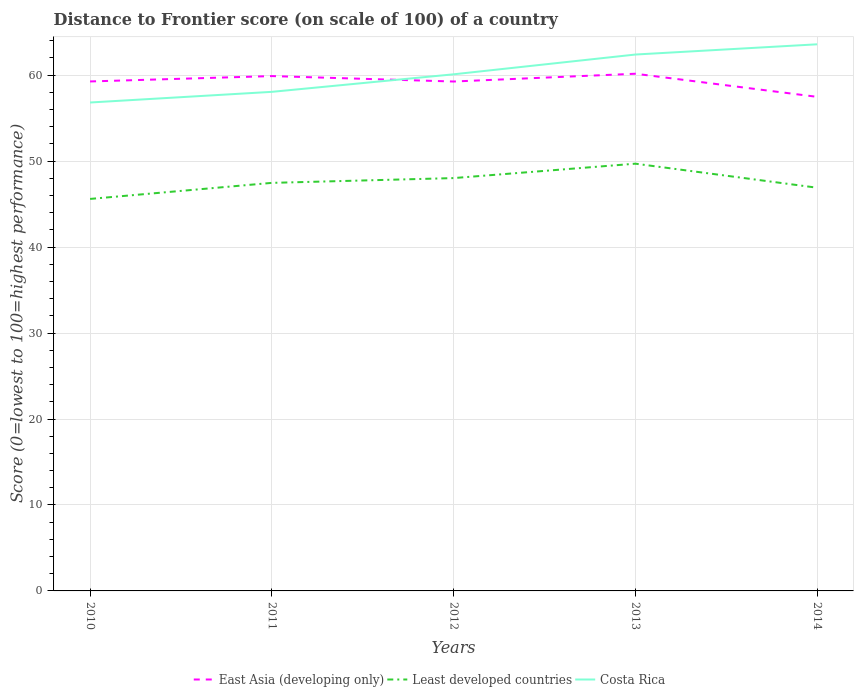Does the line corresponding to East Asia (developing only) intersect with the line corresponding to Least developed countries?
Keep it short and to the point. No. Across all years, what is the maximum distance to frontier score of in Least developed countries?
Provide a short and direct response. 45.6. What is the total distance to frontier score of in East Asia (developing only) in the graph?
Ensure brevity in your answer.  2.69. What is the difference between the highest and the second highest distance to frontier score of in Costa Rica?
Your answer should be compact. 6.77. Is the distance to frontier score of in Least developed countries strictly greater than the distance to frontier score of in East Asia (developing only) over the years?
Offer a terse response. Yes. How many lines are there?
Provide a succinct answer. 3. How many years are there in the graph?
Give a very brief answer. 5. What is the difference between two consecutive major ticks on the Y-axis?
Offer a terse response. 10. Does the graph contain any zero values?
Ensure brevity in your answer.  No. Does the graph contain grids?
Keep it short and to the point. Yes. How many legend labels are there?
Give a very brief answer. 3. How are the legend labels stacked?
Your response must be concise. Horizontal. What is the title of the graph?
Keep it short and to the point. Distance to Frontier score (on scale of 100) of a country. Does "Tuvalu" appear as one of the legend labels in the graph?
Your answer should be compact. No. What is the label or title of the Y-axis?
Give a very brief answer. Score (0=lowest to 100=highest performance). What is the Score (0=lowest to 100=highest performance) in East Asia (developing only) in 2010?
Provide a short and direct response. 59.27. What is the Score (0=lowest to 100=highest performance) of Least developed countries in 2010?
Make the answer very short. 45.6. What is the Score (0=lowest to 100=highest performance) of Costa Rica in 2010?
Offer a very short reply. 56.82. What is the Score (0=lowest to 100=highest performance) in East Asia (developing only) in 2011?
Make the answer very short. 59.89. What is the Score (0=lowest to 100=highest performance) of Least developed countries in 2011?
Offer a very short reply. 47.47. What is the Score (0=lowest to 100=highest performance) of Costa Rica in 2011?
Your answer should be very brief. 58.06. What is the Score (0=lowest to 100=highest performance) in East Asia (developing only) in 2012?
Your answer should be very brief. 59.26. What is the Score (0=lowest to 100=highest performance) in Least developed countries in 2012?
Give a very brief answer. 48.03. What is the Score (0=lowest to 100=highest performance) in Costa Rica in 2012?
Provide a short and direct response. 60.1. What is the Score (0=lowest to 100=highest performance) in East Asia (developing only) in 2013?
Your answer should be very brief. 60.17. What is the Score (0=lowest to 100=highest performance) of Least developed countries in 2013?
Offer a terse response. 49.7. What is the Score (0=lowest to 100=highest performance) of Costa Rica in 2013?
Provide a short and direct response. 62.4. What is the Score (0=lowest to 100=highest performance) in East Asia (developing only) in 2014?
Keep it short and to the point. 57.48. What is the Score (0=lowest to 100=highest performance) in Least developed countries in 2014?
Keep it short and to the point. 46.91. What is the Score (0=lowest to 100=highest performance) of Costa Rica in 2014?
Offer a terse response. 63.59. Across all years, what is the maximum Score (0=lowest to 100=highest performance) of East Asia (developing only)?
Your answer should be compact. 60.17. Across all years, what is the maximum Score (0=lowest to 100=highest performance) of Least developed countries?
Provide a succinct answer. 49.7. Across all years, what is the maximum Score (0=lowest to 100=highest performance) of Costa Rica?
Your response must be concise. 63.59. Across all years, what is the minimum Score (0=lowest to 100=highest performance) in East Asia (developing only)?
Offer a very short reply. 57.48. Across all years, what is the minimum Score (0=lowest to 100=highest performance) in Least developed countries?
Keep it short and to the point. 45.6. Across all years, what is the minimum Score (0=lowest to 100=highest performance) of Costa Rica?
Your answer should be very brief. 56.82. What is the total Score (0=lowest to 100=highest performance) in East Asia (developing only) in the graph?
Provide a succinct answer. 296.07. What is the total Score (0=lowest to 100=highest performance) in Least developed countries in the graph?
Make the answer very short. 237.71. What is the total Score (0=lowest to 100=highest performance) of Costa Rica in the graph?
Offer a very short reply. 300.97. What is the difference between the Score (0=lowest to 100=highest performance) of East Asia (developing only) in 2010 and that in 2011?
Make the answer very short. -0.63. What is the difference between the Score (0=lowest to 100=highest performance) in Least developed countries in 2010 and that in 2011?
Make the answer very short. -1.87. What is the difference between the Score (0=lowest to 100=highest performance) of Costa Rica in 2010 and that in 2011?
Provide a short and direct response. -1.24. What is the difference between the Score (0=lowest to 100=highest performance) of East Asia (developing only) in 2010 and that in 2012?
Offer a terse response. 0.01. What is the difference between the Score (0=lowest to 100=highest performance) of Least developed countries in 2010 and that in 2012?
Provide a short and direct response. -2.43. What is the difference between the Score (0=lowest to 100=highest performance) in Costa Rica in 2010 and that in 2012?
Give a very brief answer. -3.28. What is the difference between the Score (0=lowest to 100=highest performance) in East Asia (developing only) in 2010 and that in 2013?
Offer a very short reply. -0.9. What is the difference between the Score (0=lowest to 100=highest performance) of Least developed countries in 2010 and that in 2013?
Offer a terse response. -4.1. What is the difference between the Score (0=lowest to 100=highest performance) in Costa Rica in 2010 and that in 2013?
Offer a terse response. -5.58. What is the difference between the Score (0=lowest to 100=highest performance) in East Asia (developing only) in 2010 and that in 2014?
Give a very brief answer. 1.79. What is the difference between the Score (0=lowest to 100=highest performance) in Least developed countries in 2010 and that in 2014?
Your answer should be compact. -1.3. What is the difference between the Score (0=lowest to 100=highest performance) in Costa Rica in 2010 and that in 2014?
Give a very brief answer. -6.77. What is the difference between the Score (0=lowest to 100=highest performance) of East Asia (developing only) in 2011 and that in 2012?
Your response must be concise. 0.63. What is the difference between the Score (0=lowest to 100=highest performance) in Least developed countries in 2011 and that in 2012?
Provide a short and direct response. -0.56. What is the difference between the Score (0=lowest to 100=highest performance) in Costa Rica in 2011 and that in 2012?
Give a very brief answer. -2.04. What is the difference between the Score (0=lowest to 100=highest performance) in East Asia (developing only) in 2011 and that in 2013?
Your answer should be very brief. -0.27. What is the difference between the Score (0=lowest to 100=highest performance) of Least developed countries in 2011 and that in 2013?
Keep it short and to the point. -2.23. What is the difference between the Score (0=lowest to 100=highest performance) of Costa Rica in 2011 and that in 2013?
Your answer should be very brief. -4.34. What is the difference between the Score (0=lowest to 100=highest performance) of East Asia (developing only) in 2011 and that in 2014?
Your answer should be very brief. 2.42. What is the difference between the Score (0=lowest to 100=highest performance) in Least developed countries in 2011 and that in 2014?
Keep it short and to the point. 0.57. What is the difference between the Score (0=lowest to 100=highest performance) of Costa Rica in 2011 and that in 2014?
Make the answer very short. -5.53. What is the difference between the Score (0=lowest to 100=highest performance) of East Asia (developing only) in 2012 and that in 2013?
Offer a terse response. -0.91. What is the difference between the Score (0=lowest to 100=highest performance) of Least developed countries in 2012 and that in 2013?
Your answer should be compact. -1.68. What is the difference between the Score (0=lowest to 100=highest performance) of East Asia (developing only) in 2012 and that in 2014?
Make the answer very short. 1.78. What is the difference between the Score (0=lowest to 100=highest performance) in Least developed countries in 2012 and that in 2014?
Offer a very short reply. 1.12. What is the difference between the Score (0=lowest to 100=highest performance) in Costa Rica in 2012 and that in 2014?
Ensure brevity in your answer.  -3.49. What is the difference between the Score (0=lowest to 100=highest performance) in East Asia (developing only) in 2013 and that in 2014?
Your response must be concise. 2.69. What is the difference between the Score (0=lowest to 100=highest performance) of Least developed countries in 2013 and that in 2014?
Ensure brevity in your answer.  2.8. What is the difference between the Score (0=lowest to 100=highest performance) in Costa Rica in 2013 and that in 2014?
Ensure brevity in your answer.  -1.19. What is the difference between the Score (0=lowest to 100=highest performance) of East Asia (developing only) in 2010 and the Score (0=lowest to 100=highest performance) of Least developed countries in 2011?
Your answer should be compact. 11.8. What is the difference between the Score (0=lowest to 100=highest performance) in East Asia (developing only) in 2010 and the Score (0=lowest to 100=highest performance) in Costa Rica in 2011?
Your answer should be compact. 1.21. What is the difference between the Score (0=lowest to 100=highest performance) of Least developed countries in 2010 and the Score (0=lowest to 100=highest performance) of Costa Rica in 2011?
Keep it short and to the point. -12.46. What is the difference between the Score (0=lowest to 100=highest performance) in East Asia (developing only) in 2010 and the Score (0=lowest to 100=highest performance) in Least developed countries in 2012?
Your answer should be very brief. 11.24. What is the difference between the Score (0=lowest to 100=highest performance) of East Asia (developing only) in 2010 and the Score (0=lowest to 100=highest performance) of Costa Rica in 2012?
Make the answer very short. -0.83. What is the difference between the Score (0=lowest to 100=highest performance) of Least developed countries in 2010 and the Score (0=lowest to 100=highest performance) of Costa Rica in 2012?
Make the answer very short. -14.5. What is the difference between the Score (0=lowest to 100=highest performance) in East Asia (developing only) in 2010 and the Score (0=lowest to 100=highest performance) in Least developed countries in 2013?
Keep it short and to the point. 9.57. What is the difference between the Score (0=lowest to 100=highest performance) in East Asia (developing only) in 2010 and the Score (0=lowest to 100=highest performance) in Costa Rica in 2013?
Make the answer very short. -3.13. What is the difference between the Score (0=lowest to 100=highest performance) of Least developed countries in 2010 and the Score (0=lowest to 100=highest performance) of Costa Rica in 2013?
Give a very brief answer. -16.8. What is the difference between the Score (0=lowest to 100=highest performance) in East Asia (developing only) in 2010 and the Score (0=lowest to 100=highest performance) in Least developed countries in 2014?
Give a very brief answer. 12.36. What is the difference between the Score (0=lowest to 100=highest performance) of East Asia (developing only) in 2010 and the Score (0=lowest to 100=highest performance) of Costa Rica in 2014?
Your answer should be compact. -4.32. What is the difference between the Score (0=lowest to 100=highest performance) in Least developed countries in 2010 and the Score (0=lowest to 100=highest performance) in Costa Rica in 2014?
Your answer should be very brief. -17.99. What is the difference between the Score (0=lowest to 100=highest performance) in East Asia (developing only) in 2011 and the Score (0=lowest to 100=highest performance) in Least developed countries in 2012?
Provide a short and direct response. 11.87. What is the difference between the Score (0=lowest to 100=highest performance) of East Asia (developing only) in 2011 and the Score (0=lowest to 100=highest performance) of Costa Rica in 2012?
Your response must be concise. -0.21. What is the difference between the Score (0=lowest to 100=highest performance) of Least developed countries in 2011 and the Score (0=lowest to 100=highest performance) of Costa Rica in 2012?
Your response must be concise. -12.63. What is the difference between the Score (0=lowest to 100=highest performance) of East Asia (developing only) in 2011 and the Score (0=lowest to 100=highest performance) of Least developed countries in 2013?
Keep it short and to the point. 10.19. What is the difference between the Score (0=lowest to 100=highest performance) of East Asia (developing only) in 2011 and the Score (0=lowest to 100=highest performance) of Costa Rica in 2013?
Provide a short and direct response. -2.51. What is the difference between the Score (0=lowest to 100=highest performance) in Least developed countries in 2011 and the Score (0=lowest to 100=highest performance) in Costa Rica in 2013?
Ensure brevity in your answer.  -14.93. What is the difference between the Score (0=lowest to 100=highest performance) in East Asia (developing only) in 2011 and the Score (0=lowest to 100=highest performance) in Least developed countries in 2014?
Make the answer very short. 12.99. What is the difference between the Score (0=lowest to 100=highest performance) of East Asia (developing only) in 2011 and the Score (0=lowest to 100=highest performance) of Costa Rica in 2014?
Offer a terse response. -3.7. What is the difference between the Score (0=lowest to 100=highest performance) of Least developed countries in 2011 and the Score (0=lowest to 100=highest performance) of Costa Rica in 2014?
Your answer should be compact. -16.12. What is the difference between the Score (0=lowest to 100=highest performance) of East Asia (developing only) in 2012 and the Score (0=lowest to 100=highest performance) of Least developed countries in 2013?
Offer a terse response. 9.56. What is the difference between the Score (0=lowest to 100=highest performance) of East Asia (developing only) in 2012 and the Score (0=lowest to 100=highest performance) of Costa Rica in 2013?
Provide a short and direct response. -3.14. What is the difference between the Score (0=lowest to 100=highest performance) in Least developed countries in 2012 and the Score (0=lowest to 100=highest performance) in Costa Rica in 2013?
Offer a terse response. -14.37. What is the difference between the Score (0=lowest to 100=highest performance) in East Asia (developing only) in 2012 and the Score (0=lowest to 100=highest performance) in Least developed countries in 2014?
Give a very brief answer. 12.36. What is the difference between the Score (0=lowest to 100=highest performance) in East Asia (developing only) in 2012 and the Score (0=lowest to 100=highest performance) in Costa Rica in 2014?
Your answer should be very brief. -4.33. What is the difference between the Score (0=lowest to 100=highest performance) of Least developed countries in 2012 and the Score (0=lowest to 100=highest performance) of Costa Rica in 2014?
Keep it short and to the point. -15.56. What is the difference between the Score (0=lowest to 100=highest performance) in East Asia (developing only) in 2013 and the Score (0=lowest to 100=highest performance) in Least developed countries in 2014?
Your response must be concise. 13.26. What is the difference between the Score (0=lowest to 100=highest performance) of East Asia (developing only) in 2013 and the Score (0=lowest to 100=highest performance) of Costa Rica in 2014?
Your answer should be compact. -3.42. What is the difference between the Score (0=lowest to 100=highest performance) of Least developed countries in 2013 and the Score (0=lowest to 100=highest performance) of Costa Rica in 2014?
Provide a short and direct response. -13.89. What is the average Score (0=lowest to 100=highest performance) in East Asia (developing only) per year?
Your answer should be very brief. 59.21. What is the average Score (0=lowest to 100=highest performance) of Least developed countries per year?
Offer a very short reply. 47.54. What is the average Score (0=lowest to 100=highest performance) in Costa Rica per year?
Make the answer very short. 60.19. In the year 2010, what is the difference between the Score (0=lowest to 100=highest performance) in East Asia (developing only) and Score (0=lowest to 100=highest performance) in Least developed countries?
Your answer should be compact. 13.67. In the year 2010, what is the difference between the Score (0=lowest to 100=highest performance) in East Asia (developing only) and Score (0=lowest to 100=highest performance) in Costa Rica?
Your response must be concise. 2.45. In the year 2010, what is the difference between the Score (0=lowest to 100=highest performance) of Least developed countries and Score (0=lowest to 100=highest performance) of Costa Rica?
Provide a short and direct response. -11.22. In the year 2011, what is the difference between the Score (0=lowest to 100=highest performance) in East Asia (developing only) and Score (0=lowest to 100=highest performance) in Least developed countries?
Give a very brief answer. 12.42. In the year 2011, what is the difference between the Score (0=lowest to 100=highest performance) of East Asia (developing only) and Score (0=lowest to 100=highest performance) of Costa Rica?
Your answer should be compact. 1.83. In the year 2011, what is the difference between the Score (0=lowest to 100=highest performance) of Least developed countries and Score (0=lowest to 100=highest performance) of Costa Rica?
Your answer should be very brief. -10.59. In the year 2012, what is the difference between the Score (0=lowest to 100=highest performance) in East Asia (developing only) and Score (0=lowest to 100=highest performance) in Least developed countries?
Your answer should be very brief. 11.23. In the year 2012, what is the difference between the Score (0=lowest to 100=highest performance) of East Asia (developing only) and Score (0=lowest to 100=highest performance) of Costa Rica?
Provide a short and direct response. -0.84. In the year 2012, what is the difference between the Score (0=lowest to 100=highest performance) in Least developed countries and Score (0=lowest to 100=highest performance) in Costa Rica?
Your answer should be compact. -12.07. In the year 2013, what is the difference between the Score (0=lowest to 100=highest performance) of East Asia (developing only) and Score (0=lowest to 100=highest performance) of Least developed countries?
Provide a succinct answer. 10.46. In the year 2013, what is the difference between the Score (0=lowest to 100=highest performance) of East Asia (developing only) and Score (0=lowest to 100=highest performance) of Costa Rica?
Give a very brief answer. -2.23. In the year 2013, what is the difference between the Score (0=lowest to 100=highest performance) in Least developed countries and Score (0=lowest to 100=highest performance) in Costa Rica?
Provide a short and direct response. -12.7. In the year 2014, what is the difference between the Score (0=lowest to 100=highest performance) of East Asia (developing only) and Score (0=lowest to 100=highest performance) of Least developed countries?
Your answer should be very brief. 10.57. In the year 2014, what is the difference between the Score (0=lowest to 100=highest performance) of East Asia (developing only) and Score (0=lowest to 100=highest performance) of Costa Rica?
Offer a very short reply. -6.11. In the year 2014, what is the difference between the Score (0=lowest to 100=highest performance) of Least developed countries and Score (0=lowest to 100=highest performance) of Costa Rica?
Offer a very short reply. -16.68. What is the ratio of the Score (0=lowest to 100=highest performance) of Least developed countries in 2010 to that in 2011?
Provide a succinct answer. 0.96. What is the ratio of the Score (0=lowest to 100=highest performance) in Costa Rica in 2010 to that in 2011?
Provide a succinct answer. 0.98. What is the ratio of the Score (0=lowest to 100=highest performance) of East Asia (developing only) in 2010 to that in 2012?
Offer a very short reply. 1. What is the ratio of the Score (0=lowest to 100=highest performance) of Least developed countries in 2010 to that in 2012?
Offer a very short reply. 0.95. What is the ratio of the Score (0=lowest to 100=highest performance) of Costa Rica in 2010 to that in 2012?
Make the answer very short. 0.95. What is the ratio of the Score (0=lowest to 100=highest performance) of East Asia (developing only) in 2010 to that in 2013?
Your answer should be compact. 0.99. What is the ratio of the Score (0=lowest to 100=highest performance) in Least developed countries in 2010 to that in 2013?
Your answer should be very brief. 0.92. What is the ratio of the Score (0=lowest to 100=highest performance) in Costa Rica in 2010 to that in 2013?
Make the answer very short. 0.91. What is the ratio of the Score (0=lowest to 100=highest performance) in East Asia (developing only) in 2010 to that in 2014?
Keep it short and to the point. 1.03. What is the ratio of the Score (0=lowest to 100=highest performance) in Least developed countries in 2010 to that in 2014?
Provide a short and direct response. 0.97. What is the ratio of the Score (0=lowest to 100=highest performance) in Costa Rica in 2010 to that in 2014?
Give a very brief answer. 0.89. What is the ratio of the Score (0=lowest to 100=highest performance) in East Asia (developing only) in 2011 to that in 2012?
Your answer should be compact. 1.01. What is the ratio of the Score (0=lowest to 100=highest performance) of Least developed countries in 2011 to that in 2012?
Provide a short and direct response. 0.99. What is the ratio of the Score (0=lowest to 100=highest performance) in Costa Rica in 2011 to that in 2012?
Offer a terse response. 0.97. What is the ratio of the Score (0=lowest to 100=highest performance) in Least developed countries in 2011 to that in 2013?
Keep it short and to the point. 0.96. What is the ratio of the Score (0=lowest to 100=highest performance) of Costa Rica in 2011 to that in 2013?
Offer a very short reply. 0.93. What is the ratio of the Score (0=lowest to 100=highest performance) of East Asia (developing only) in 2011 to that in 2014?
Ensure brevity in your answer.  1.04. What is the ratio of the Score (0=lowest to 100=highest performance) in Least developed countries in 2011 to that in 2014?
Your answer should be compact. 1.01. What is the ratio of the Score (0=lowest to 100=highest performance) in Least developed countries in 2012 to that in 2013?
Your answer should be very brief. 0.97. What is the ratio of the Score (0=lowest to 100=highest performance) of Costa Rica in 2012 to that in 2013?
Provide a succinct answer. 0.96. What is the ratio of the Score (0=lowest to 100=highest performance) in East Asia (developing only) in 2012 to that in 2014?
Your response must be concise. 1.03. What is the ratio of the Score (0=lowest to 100=highest performance) in Least developed countries in 2012 to that in 2014?
Keep it short and to the point. 1.02. What is the ratio of the Score (0=lowest to 100=highest performance) in Costa Rica in 2012 to that in 2014?
Provide a short and direct response. 0.95. What is the ratio of the Score (0=lowest to 100=highest performance) in East Asia (developing only) in 2013 to that in 2014?
Offer a very short reply. 1.05. What is the ratio of the Score (0=lowest to 100=highest performance) in Least developed countries in 2013 to that in 2014?
Your answer should be compact. 1.06. What is the ratio of the Score (0=lowest to 100=highest performance) of Costa Rica in 2013 to that in 2014?
Provide a succinct answer. 0.98. What is the difference between the highest and the second highest Score (0=lowest to 100=highest performance) of East Asia (developing only)?
Provide a succinct answer. 0.27. What is the difference between the highest and the second highest Score (0=lowest to 100=highest performance) of Least developed countries?
Your answer should be very brief. 1.68. What is the difference between the highest and the second highest Score (0=lowest to 100=highest performance) in Costa Rica?
Provide a succinct answer. 1.19. What is the difference between the highest and the lowest Score (0=lowest to 100=highest performance) in East Asia (developing only)?
Provide a short and direct response. 2.69. What is the difference between the highest and the lowest Score (0=lowest to 100=highest performance) of Least developed countries?
Your answer should be very brief. 4.1. What is the difference between the highest and the lowest Score (0=lowest to 100=highest performance) in Costa Rica?
Your answer should be compact. 6.77. 